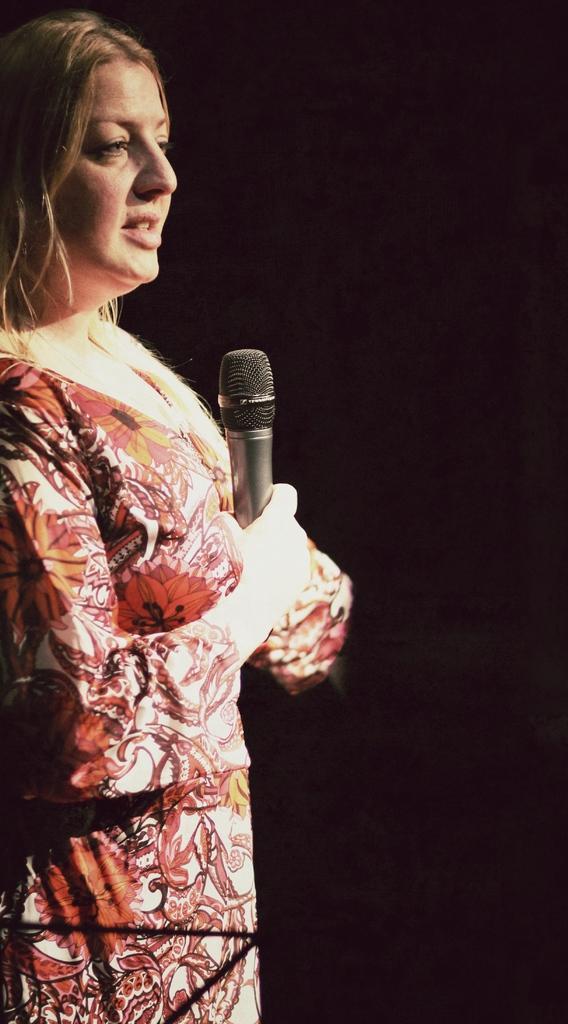Please provide a concise description of this image. In the image there is a woman stood with mic in her hand on the left side. 